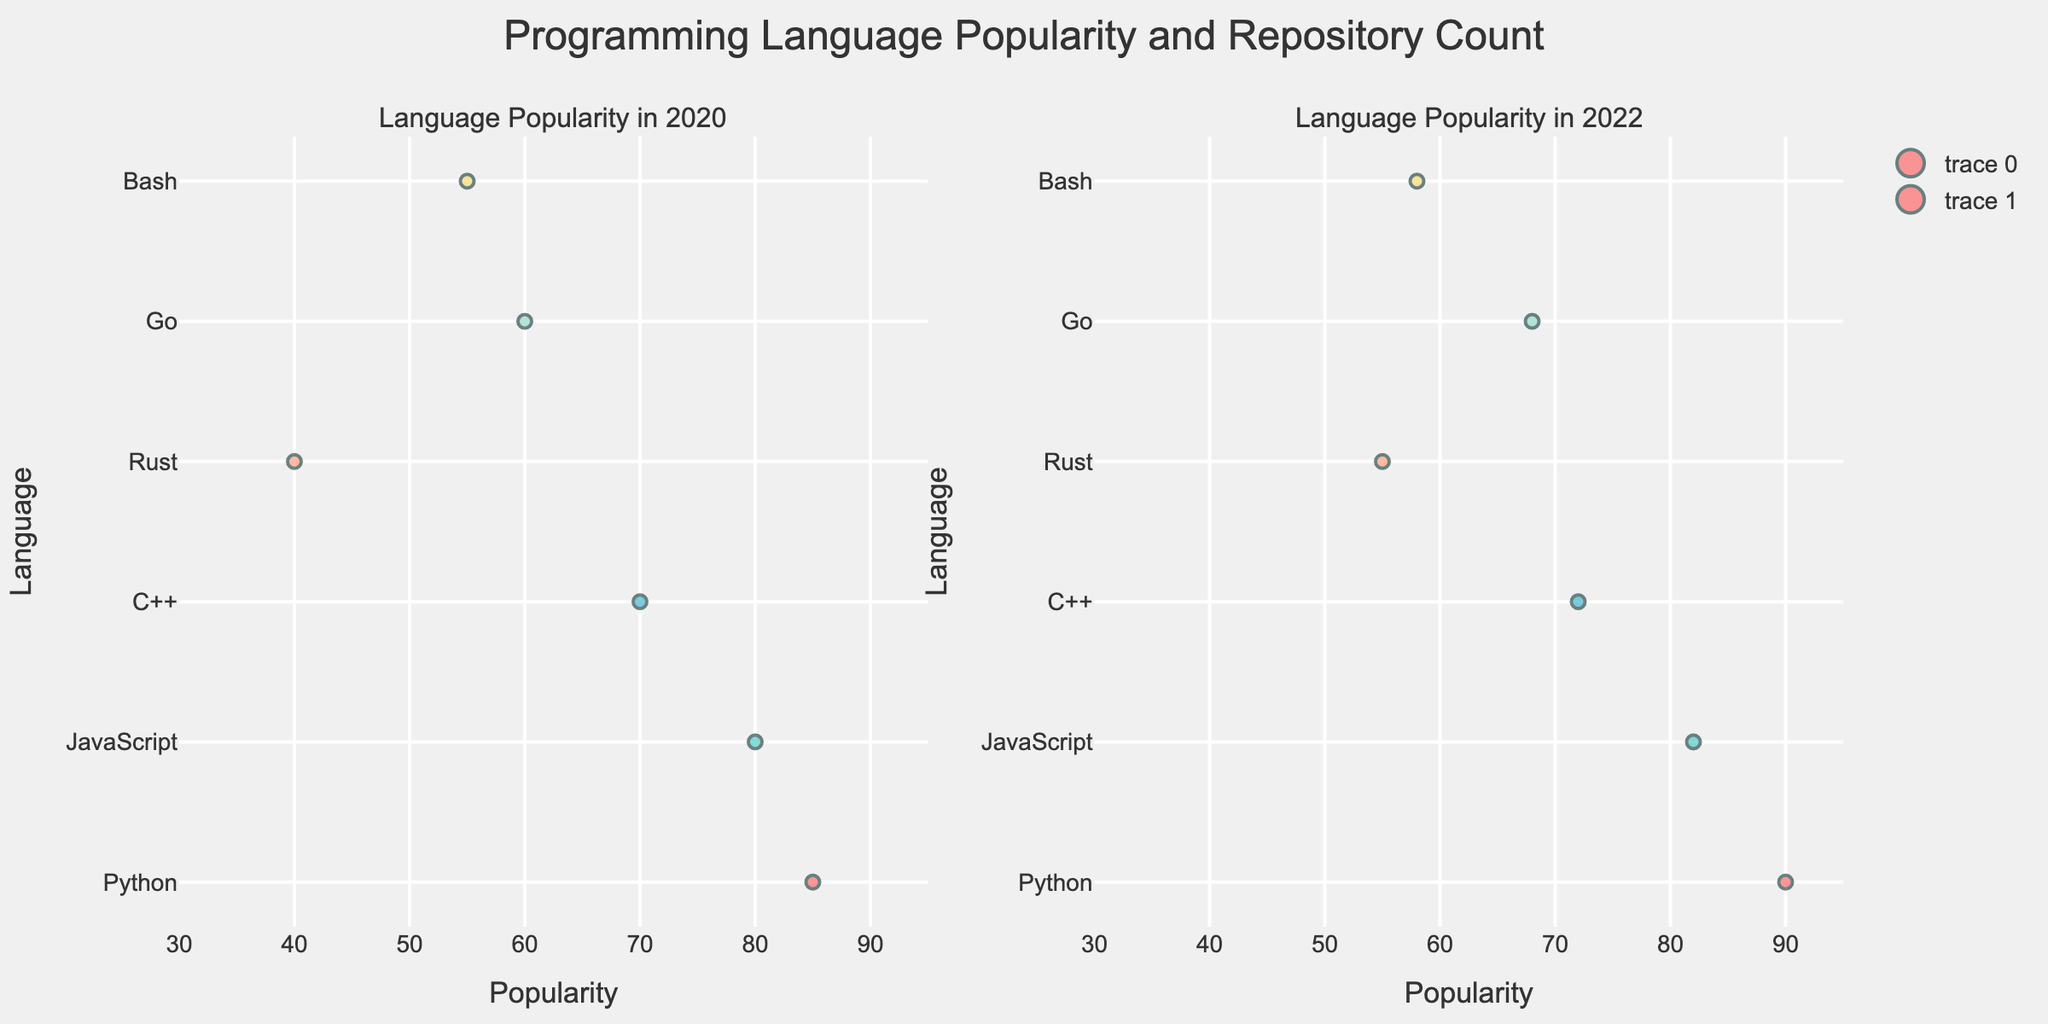what is the title of the figure? The title is usually located at the top of the figure. It summarizes the main subject of the figure. In this case, the title provided in the code is "Economic Indicators vs. Presidential Approval by Region."
Answer: Economic Indicators vs. Presidential Approval by Region how many regions are represented in the figure? The figure uses different symbols and colors to represent various regions. Referring to the provided data and code, there are 12 regions mentioned (Northeast, Midwest, South, West, New England, Mid-Atlantic, Southeast, Southwest, Pacific, Mountain, Great Lakes, Plains).
Answer: 12 which economic indicator appears to have the highest average value across all regions? Visually inspecting the scatterplot matrix, we can compare the distribution of points across the different axes. 'GDP Growth' appears to have higher values on average, ranging up to 3.3, compared to 'Unemployment Rate' and 'Inflation Rate', which have lower upper limits.
Answer: GDP Growth which region has the highest presidential approval rating? By examining the 'Presidential Approval (%)' axis and locating the highest value, we can see that the South region has the highest approval rating of 55.
Answer: South is there an apparent trend between GDP growth and presidential approval across regions? Reviewing the scatterplots involving 'GDP Growth' and 'Presidential Approval (%),' one can observe a positive correlation where higher GDP growth rates tentatively align with higher approval ratings.
Answer: Yes, there is a positive trend does the unemployment rate have an observable impact on presidential approval? By inspecting the scatterplots involving 'Unemployment Rate' and 'Presidential Approval (%),' we notice that lower unemployment rates appear to be associated with higher approval ratings, indicating a negative correlation.
Answer: Yes, there is a negative impact which pair of economic indicators shows the highest spread in values when compared visually? By analyzing the scatterplot matrix, the pair 'GDP Growth' vs. 'Presidential Approval' shows a wide variation in values across regions compared to other pairs like 'Unemployment Rate' vs. 'Inflation Rate'.
Answer: GDP Growth and Presidential Approval what is the relationship between regions with high inflation rates and their presidential approval ratings? By looking at the scatterplot involving 'Inflation Rate' and 'Presidential Approval', we see a mixed pattern, but generally regions with lower inflation rates have slightly higher approval ratings.
Answer: Inverse relationship do the regions with the lowest unemployment rates have higher average GDP growth? By comparing the scatterplots with 'Unemployment Rate' and 'GDP Growth', we can see that regions with lower unemployment rates (Southwest and Pacific) tend to show higher GDP growth values.
Answer: Yes, they do how does the Mountain region compare in terms of GDP growth and presidential approval? The code mentions symbols and colors for each region; by identifying the Mountain region's specific symbol and color, we can locate it on the scatterplot and observe that it has moderate GDP growth (2.8%) and a mid-range approval rating (50%).
Answer: Moderate GDP growth and mid-range approval 